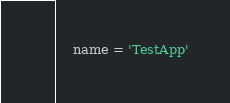<code> <loc_0><loc_0><loc_500><loc_500><_Python_>    name = 'TestApp'
</code> 